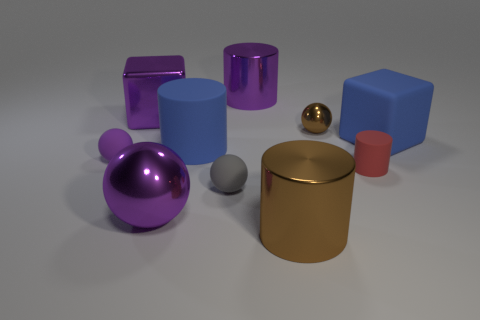Are there the same number of blue blocks that are behind the purple shiny cylinder and metal cubes?
Give a very brief answer. No. There is a purple thing that is the same size as the red object; what shape is it?
Provide a short and direct response. Sphere. What is the material of the tiny brown ball?
Keep it short and to the point. Metal. What is the color of the small thing that is to the left of the brown metal cylinder and to the right of the big purple metal block?
Make the answer very short. Gray. Are there an equal number of metallic blocks that are to the right of the brown shiny cylinder and purple blocks that are right of the tiny gray matte sphere?
Give a very brief answer. Yes. What is the color of the large cylinder that is the same material as the tiny gray sphere?
Provide a succinct answer. Blue. Do the big rubber block and the tiny matte object on the right side of the big brown thing have the same color?
Your response must be concise. No. Are there any small gray balls in front of the shiny sphere in front of the big matte object that is left of the small matte cylinder?
Your response must be concise. No. There is a purple object that is made of the same material as the tiny red cylinder; what is its shape?
Offer a very short reply. Sphere. Is there any other thing that has the same shape as the red object?
Make the answer very short. Yes. 